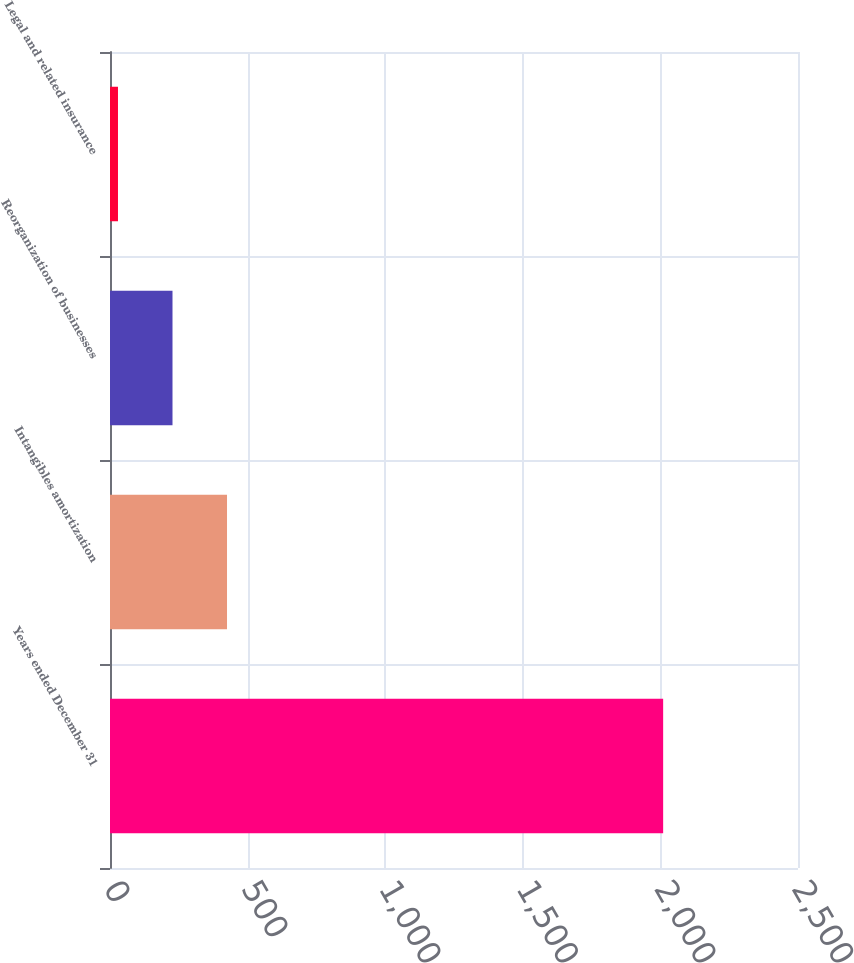Convert chart to OTSL. <chart><loc_0><loc_0><loc_500><loc_500><bar_chart><fcel>Years ended December 31<fcel>Intangibles amortization<fcel>Reorganization of businesses<fcel>Legal and related insurance<nl><fcel>2010<fcel>425.2<fcel>227.1<fcel>29<nl></chart> 